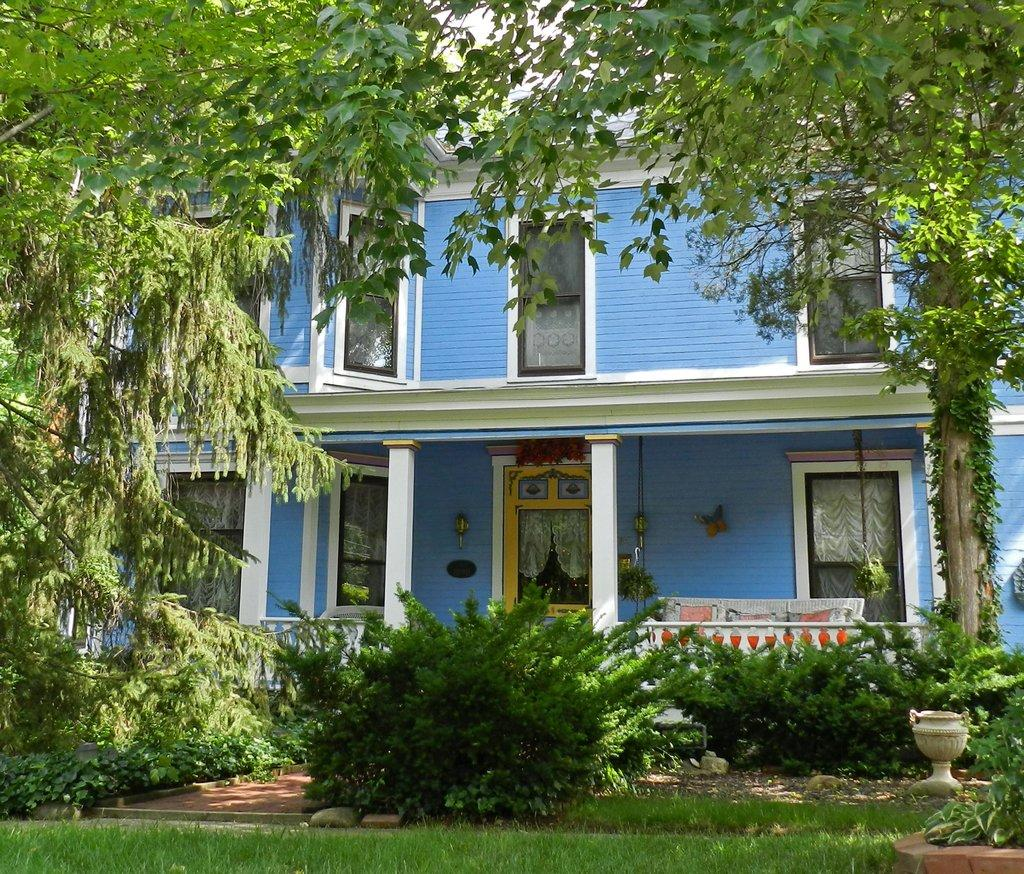What is the color of the building in the image? The building has blue color paint in the image. Where is the building located in the image? The building is in the middle of the image. What can be seen in front of the building? There are trees in front of the building. What is present at the bottom of the image? There are plants at the bottom of the image. What type of approval is required for the building in the image? There is no information about any required approval for the building in the image. Is there a collar visible on any of the plants in the image? There are no collars present on any of the plants in the image. 